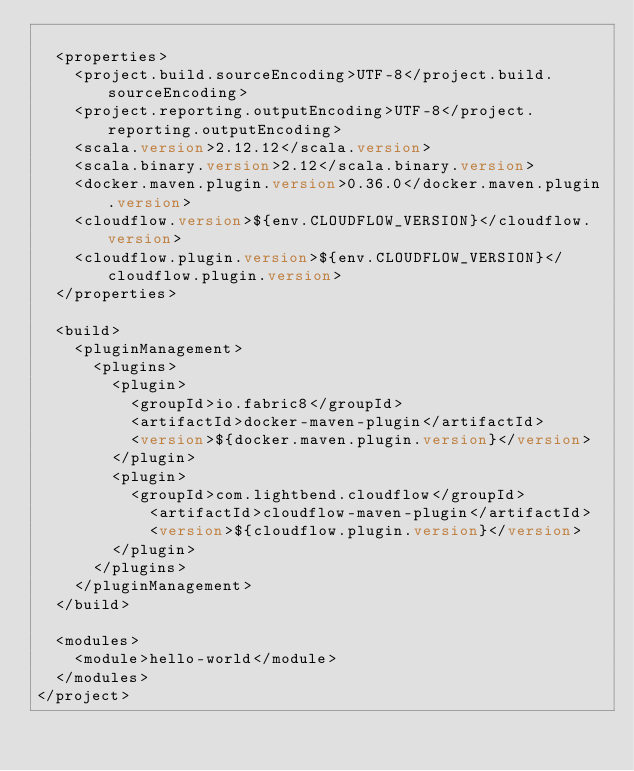Convert code to text. <code><loc_0><loc_0><loc_500><loc_500><_XML_>
  <properties>
    <project.build.sourceEncoding>UTF-8</project.build.sourceEncoding>
    <project.reporting.outputEncoding>UTF-8</project.reporting.outputEncoding>
    <scala.version>2.12.12</scala.version>
    <scala.binary.version>2.12</scala.binary.version>
    <docker.maven.plugin.version>0.36.0</docker.maven.plugin.version>
    <cloudflow.version>${env.CLOUDFLOW_VERSION}</cloudflow.version>
    <cloudflow.plugin.version>${env.CLOUDFLOW_VERSION}</cloudflow.plugin.version>
  </properties>

  <build>
    <pluginManagement>
      <plugins>
        <plugin>
          <groupId>io.fabric8</groupId>
          <artifactId>docker-maven-plugin</artifactId>
          <version>${docker.maven.plugin.version}</version>
        </plugin>
        <plugin>
          <groupId>com.lightbend.cloudflow</groupId>
            <artifactId>cloudflow-maven-plugin</artifactId>
            <version>${cloudflow.plugin.version}</version>
        </plugin>
      </plugins>
    </pluginManagement>
  </build>

  <modules>
    <module>hello-world</module>
  </modules>
</project>
</code> 